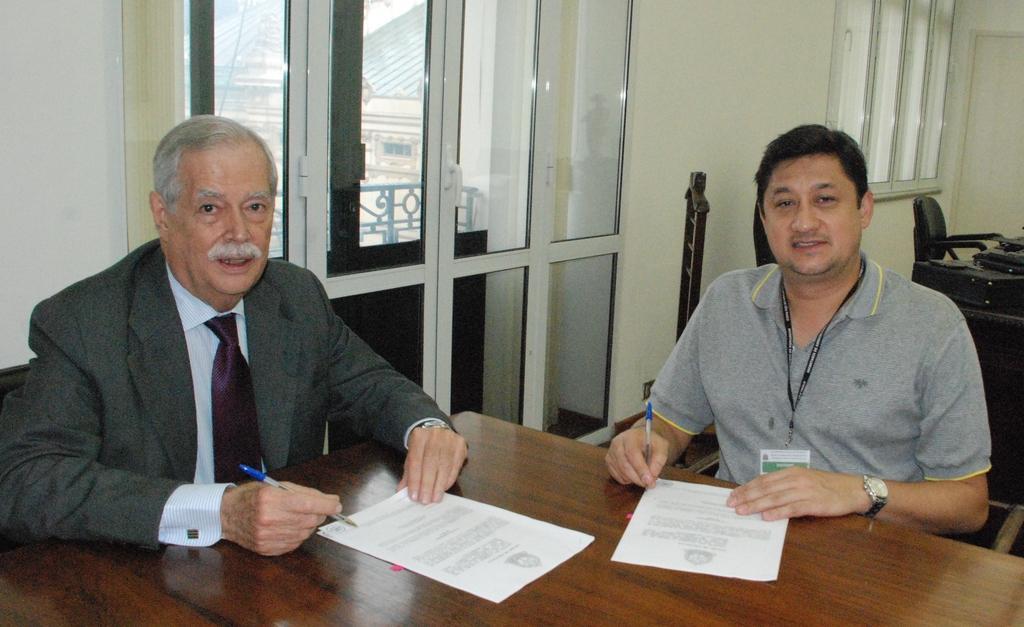Describe this image in one or two sentences. In the center of the image we can see two persons are sitting and they are smiling and they are holding pens. In front of them, we can see one table. On the table, we can see the papers. In the background there is a wall, glass, one chair and a few other objects. 